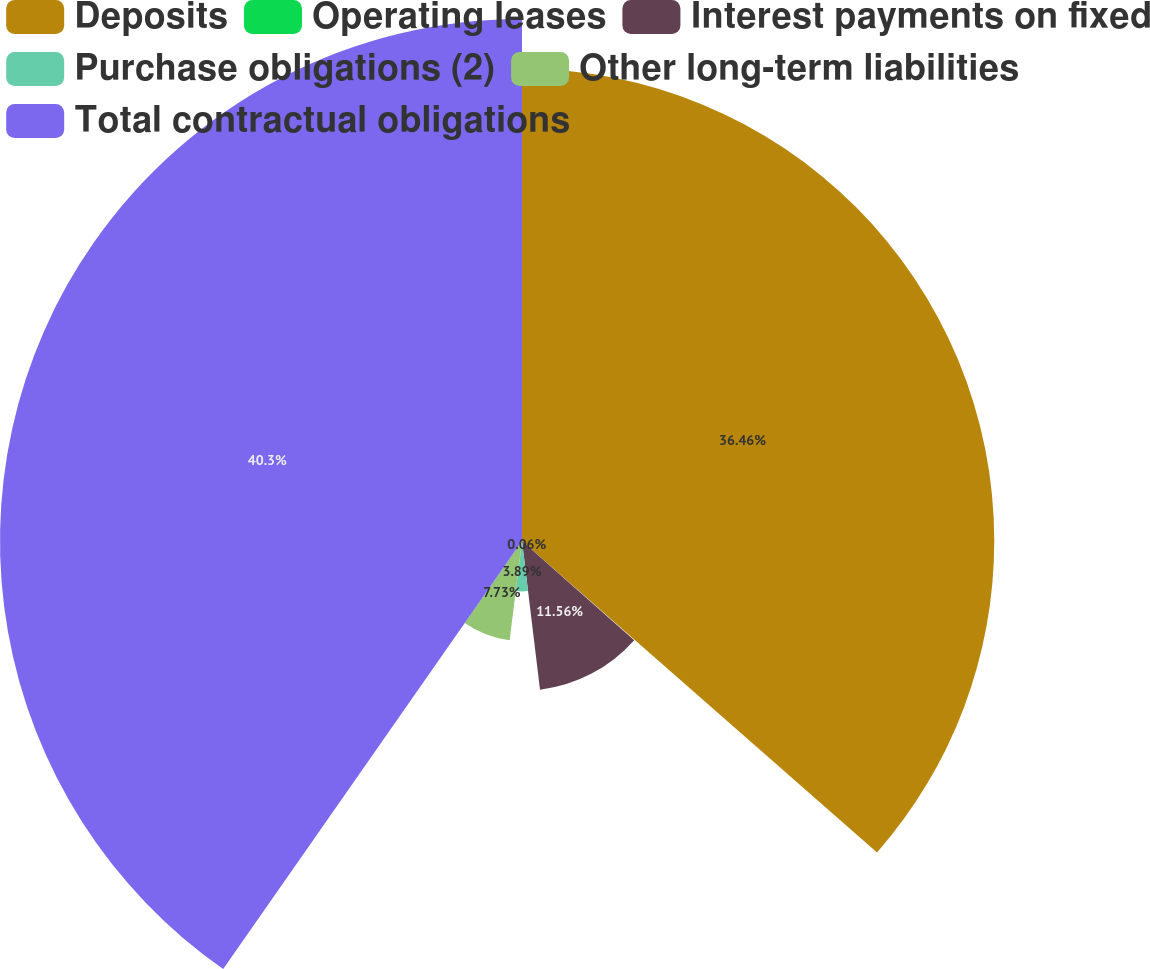Convert chart to OTSL. <chart><loc_0><loc_0><loc_500><loc_500><pie_chart><fcel>Deposits<fcel>Operating leases<fcel>Interest payments on fixed<fcel>Purchase obligations (2)<fcel>Other long-term liabilities<fcel>Total contractual obligations<nl><fcel>36.46%<fcel>0.06%<fcel>11.56%<fcel>3.89%<fcel>7.73%<fcel>40.3%<nl></chart> 